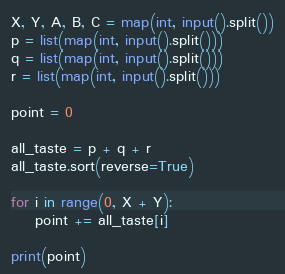Convert code to text. <code><loc_0><loc_0><loc_500><loc_500><_Python_>X, Y, A, B, C = map(int, input().split())
p = list(map(int, input().split()))
q = list(map(int, input().split()))
r = list(map(int, input().split()))

point = 0

all_taste = p + q + r
all_taste.sort(reverse=True)

for i in range(0, X + Y):
    point += all_taste[i]

print(point)</code> 